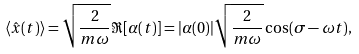<formula> <loc_0><loc_0><loc_500><loc_500>\langle { \hat { x } } ( t ) \rangle = { \sqrt { \frac { 2 } { m \omega } } } \Re [ \alpha ( t ) ] = | \alpha ( 0 ) | { \sqrt { \frac { 2 } { m \omega } } } \cos ( \sigma - \omega t ) ,</formula> 